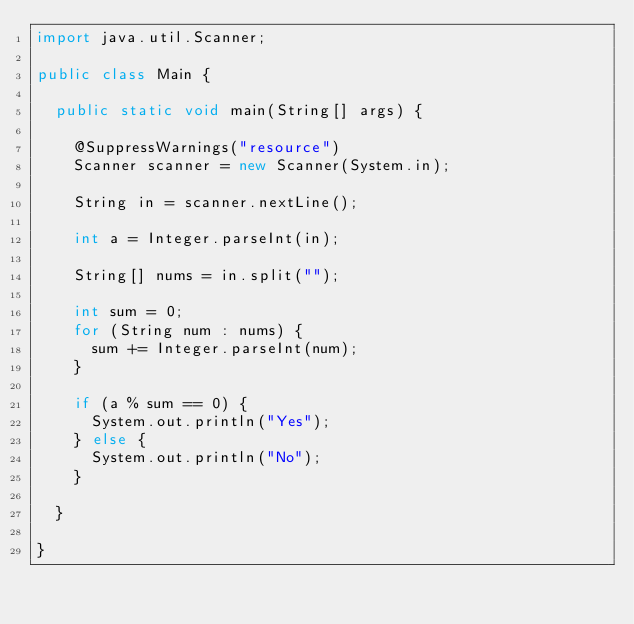Convert code to text. <code><loc_0><loc_0><loc_500><loc_500><_Java_>import java.util.Scanner;

public class Main {
	
	public static void main(String[] args) {

		@SuppressWarnings("resource")
		Scanner scanner = new Scanner(System.in);
		
		String in = scanner.nextLine();
		
		int a = Integer.parseInt(in);
		
		String[] nums = in.split("");
		
		int sum = 0;
		for (String num : nums) {
			sum += Integer.parseInt(num);
		}
		
		if (a % sum == 0) {
			System.out.println("Yes");
		} else {
			System.out.println("No");
		}
		
	}
		
}
</code> 